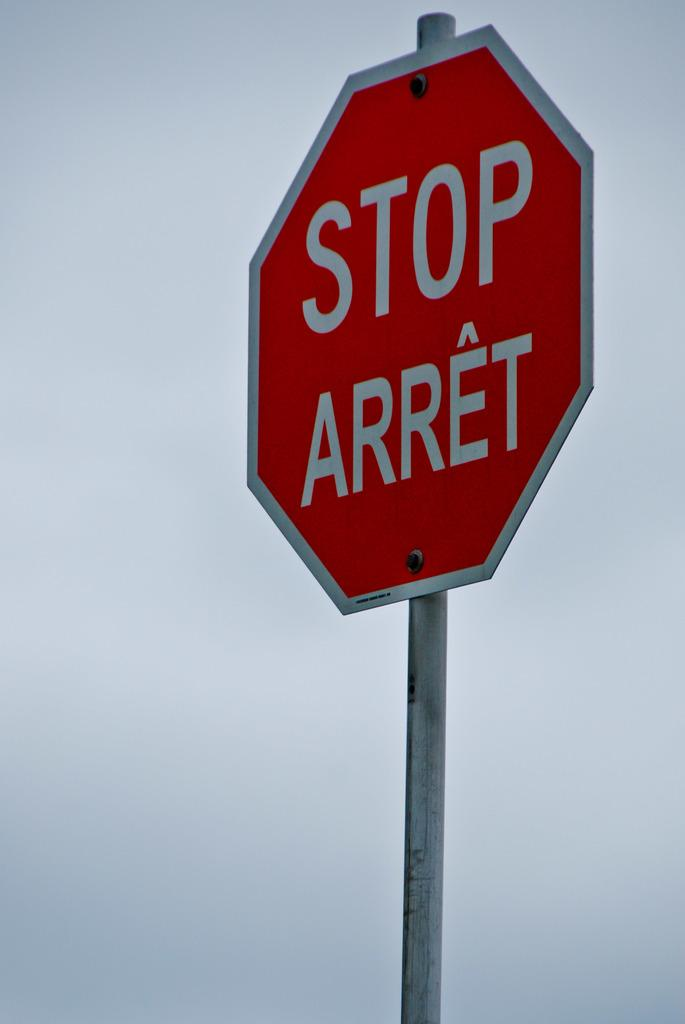<image>
Relay a brief, clear account of the picture shown. a stop sign that is outside in the daytime 